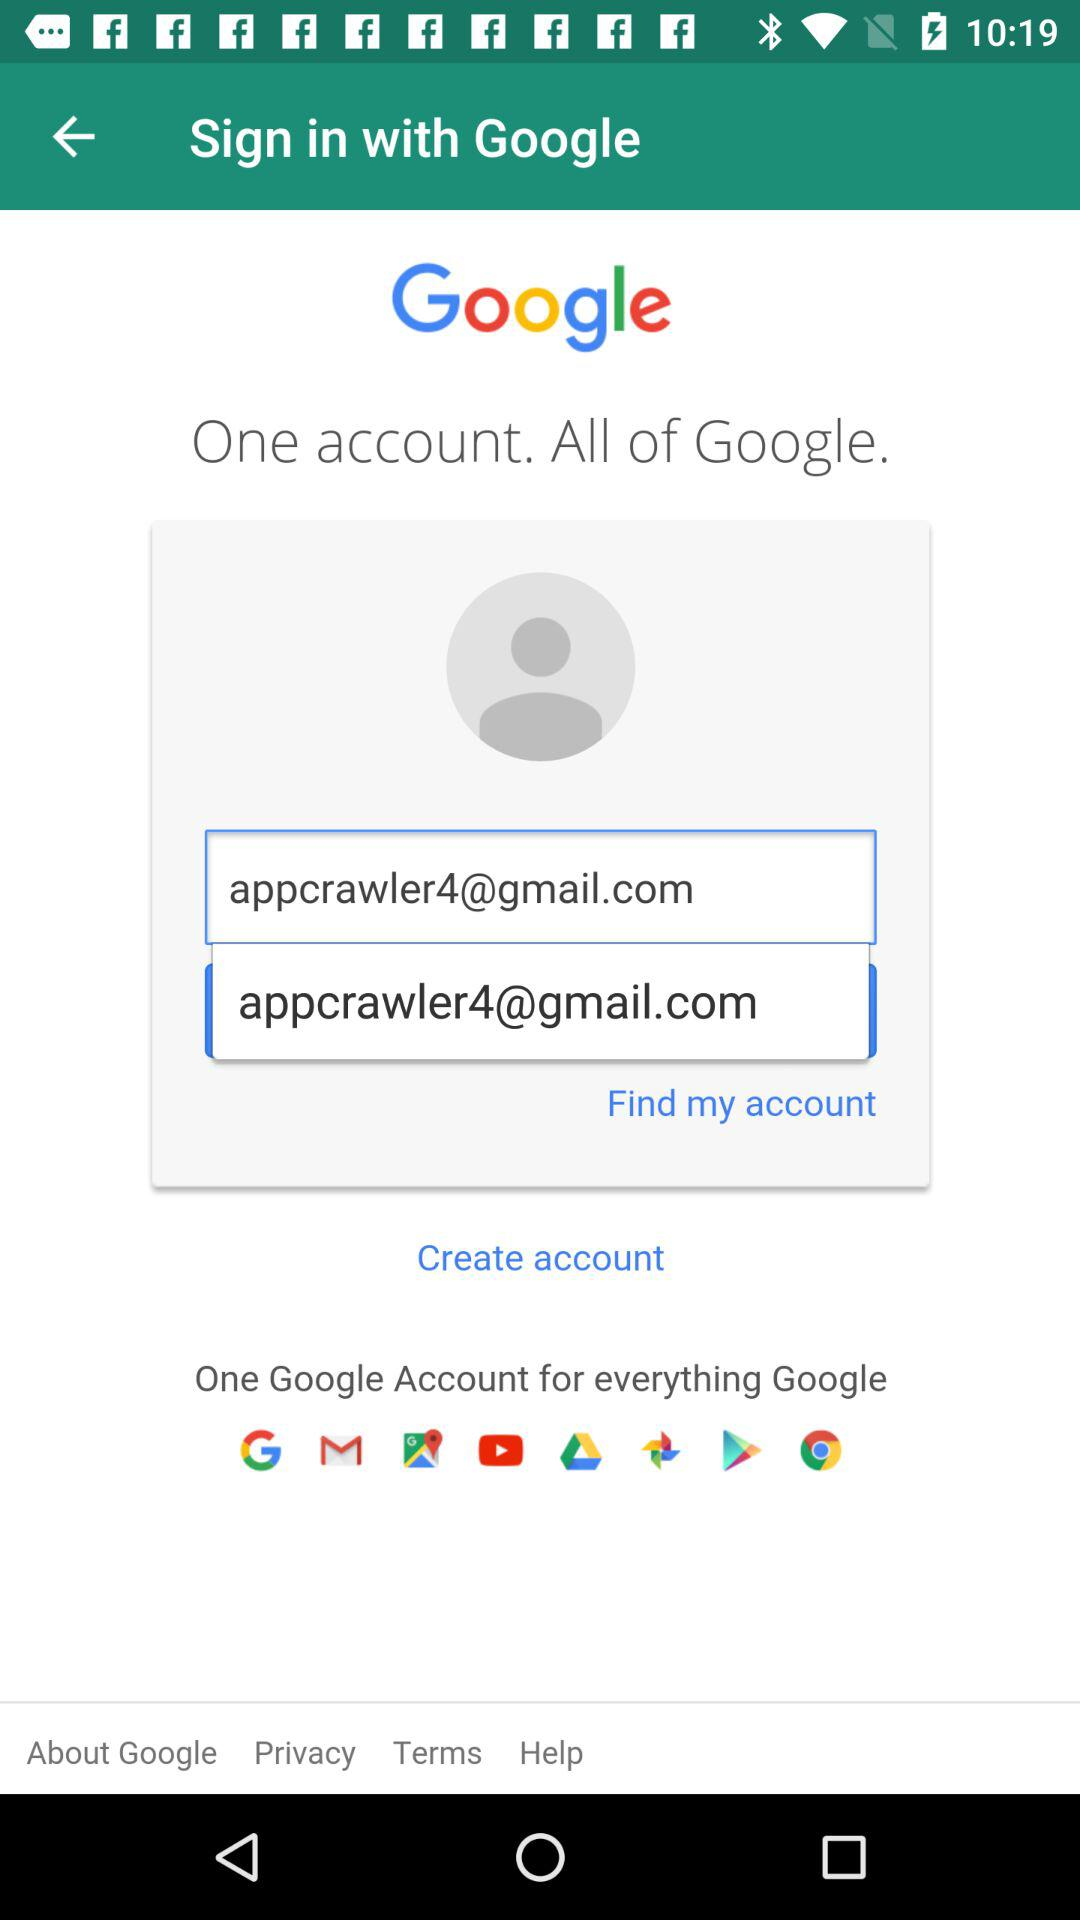What is the email address? The email address is appcrawler4@gmail.com. 